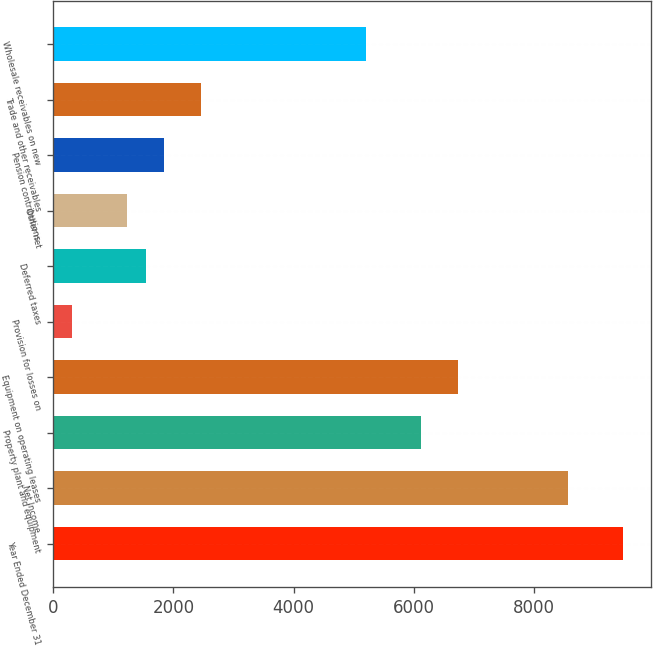Convert chart. <chart><loc_0><loc_0><loc_500><loc_500><bar_chart><fcel>Year Ended December 31<fcel>Net Income<fcel>Property plant and equipment<fcel>Equipment on operating leases<fcel>Provision for losses on<fcel>Deferred taxes<fcel>Other net<fcel>Pension contributions<fcel>Trade and other receivables<fcel>Wholesale receivables on new<nl><fcel>9486.09<fcel>8568.72<fcel>6122.4<fcel>6733.98<fcel>312.39<fcel>1535.55<fcel>1229.76<fcel>1841.34<fcel>2452.92<fcel>5205.03<nl></chart> 